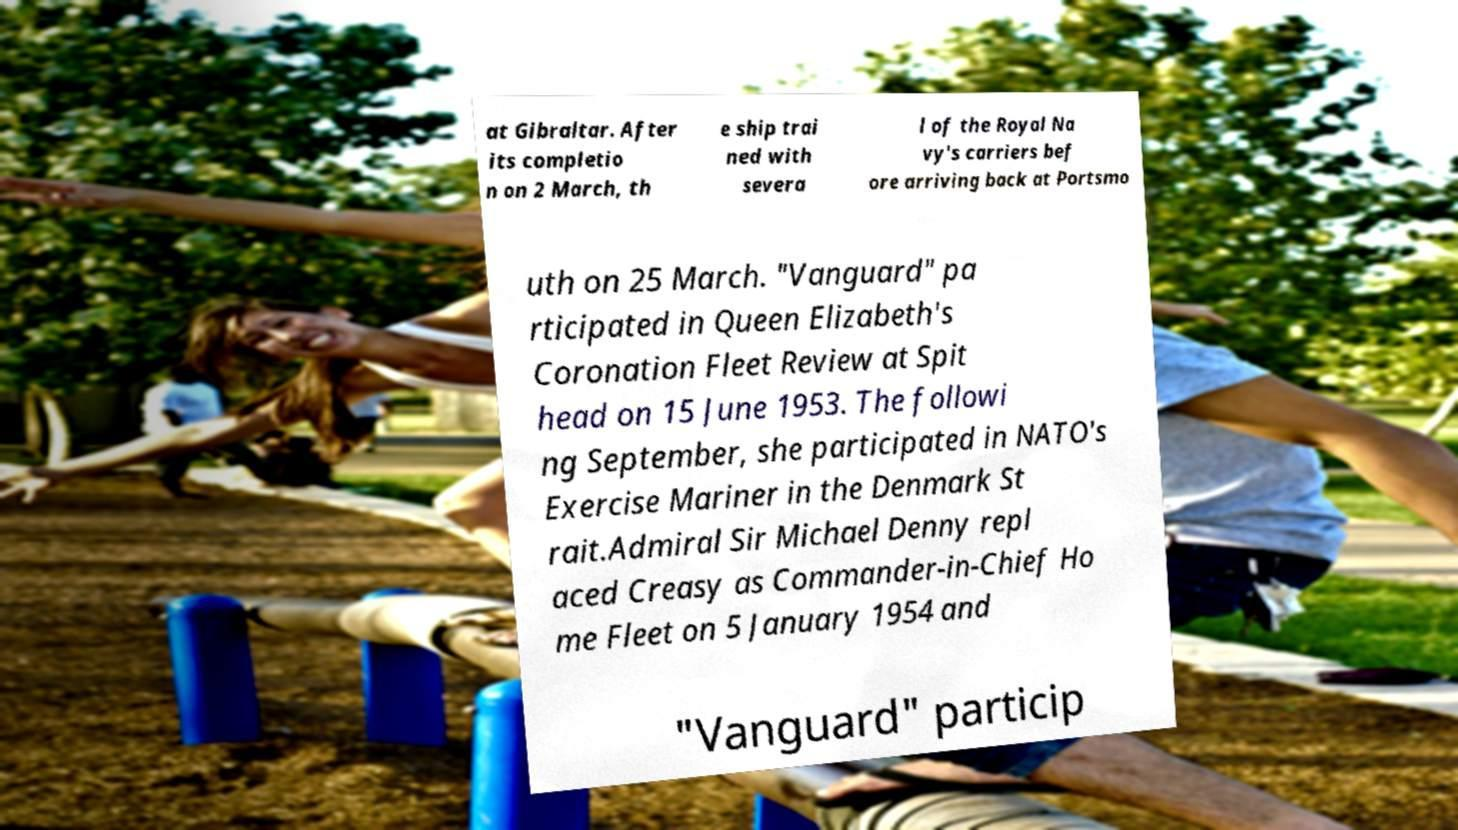Please read and relay the text visible in this image. What does it say? at Gibraltar. After its completio n on 2 March, th e ship trai ned with severa l of the Royal Na vy's carriers bef ore arriving back at Portsmo uth on 25 March. "Vanguard" pa rticipated in Queen Elizabeth's Coronation Fleet Review at Spit head on 15 June 1953. The followi ng September, she participated in NATO's Exercise Mariner in the Denmark St rait.Admiral Sir Michael Denny repl aced Creasy as Commander-in-Chief Ho me Fleet on 5 January 1954 and "Vanguard" particip 